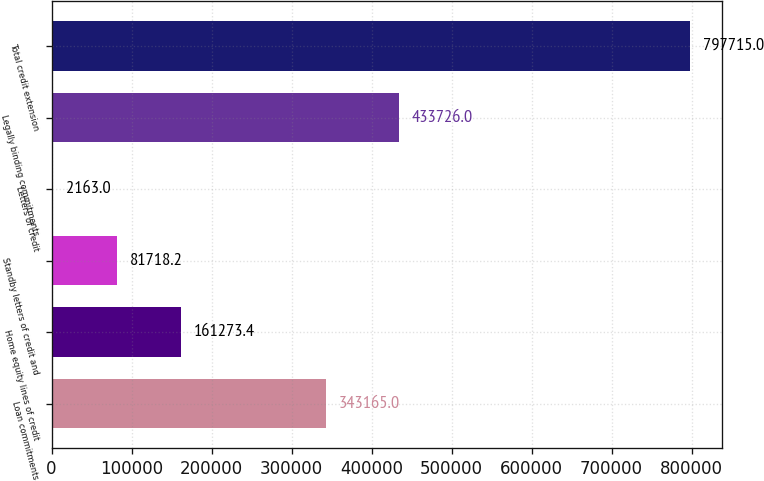Convert chart. <chart><loc_0><loc_0><loc_500><loc_500><bar_chart><fcel>Loan commitments<fcel>Home equity lines of credit<fcel>Standby letters of credit and<fcel>Letters of credit<fcel>Legally binding commitments<fcel>Total credit extension<nl><fcel>343165<fcel>161273<fcel>81718.2<fcel>2163<fcel>433726<fcel>797715<nl></chart> 